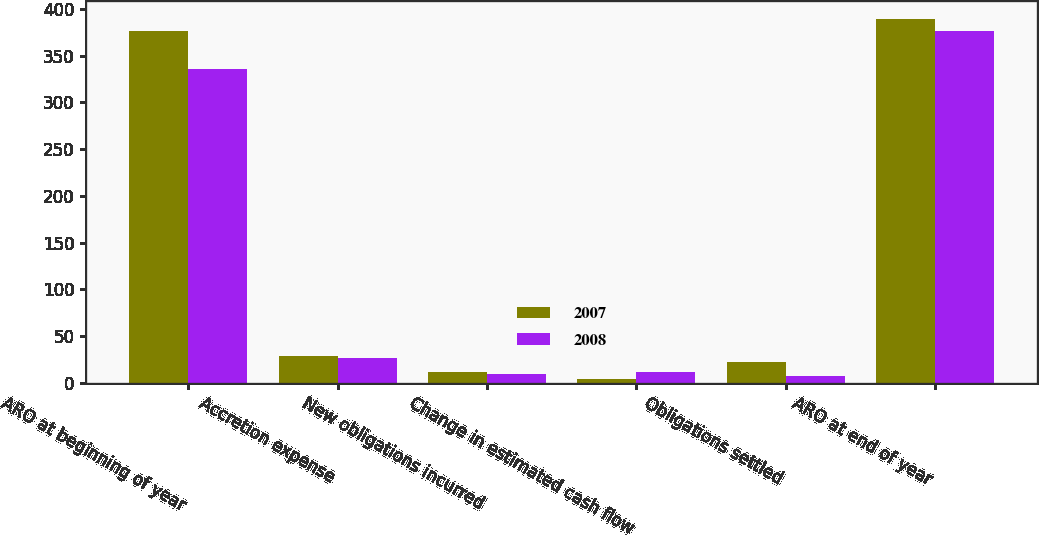Convert chart to OTSL. <chart><loc_0><loc_0><loc_500><loc_500><stacked_bar_chart><ecel><fcel>ARO at beginning of year<fcel>Accretion expense<fcel>New obligations incurred<fcel>Change in estimated cash flow<fcel>Obligations settled<fcel>ARO at end of year<nl><fcel>2007<fcel>376<fcel>29<fcel>12<fcel>4<fcel>22<fcel>389<nl><fcel>2008<fcel>336<fcel>27<fcel>9<fcel>11<fcel>7<fcel>376<nl></chart> 